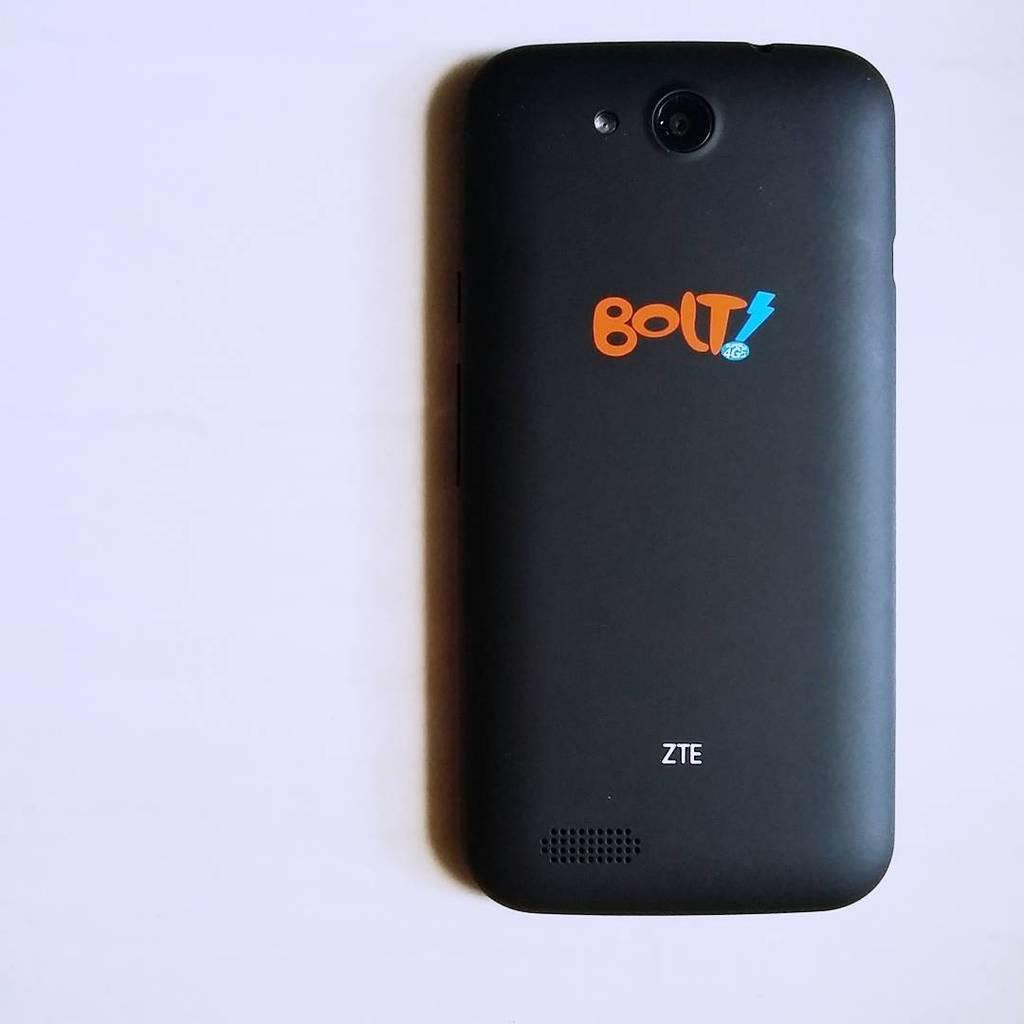<image>
Give a short and clear explanation of the subsequent image. a cell phone with the word bolt on the back 